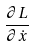Convert formula to latex. <formula><loc_0><loc_0><loc_500><loc_500>\frac { \partial L } { \partial \dot { x } }</formula> 